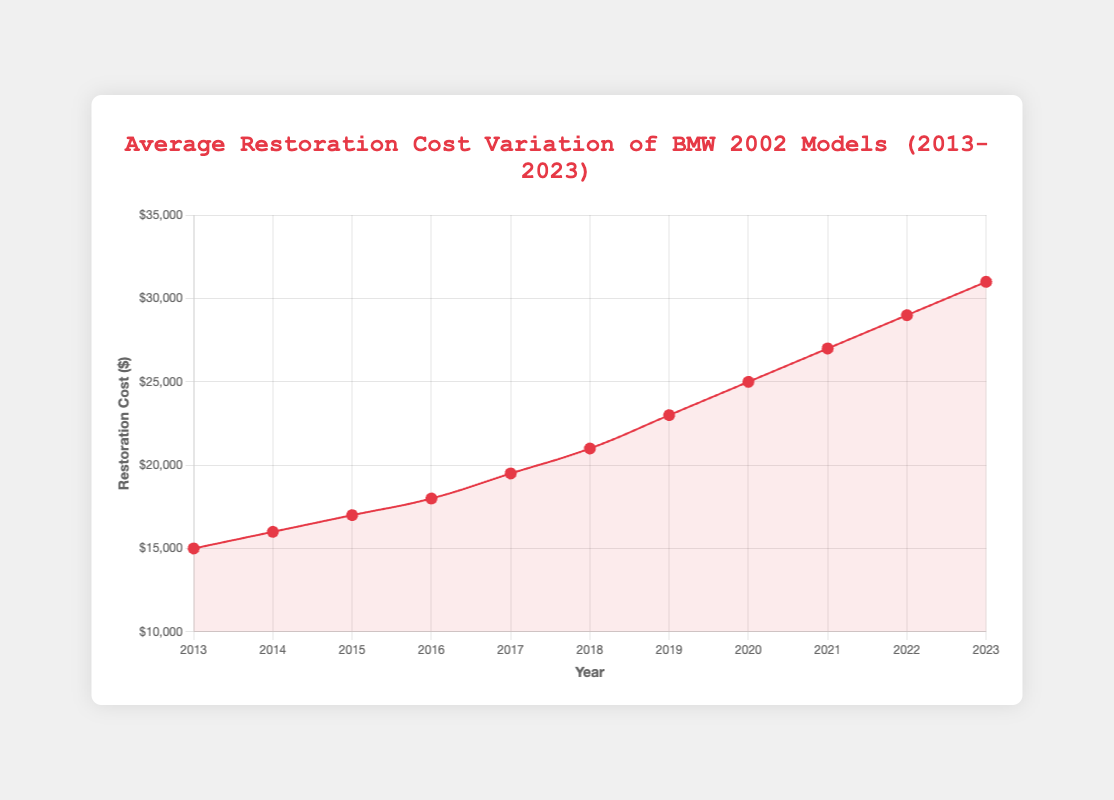What's the highest restoration cost recorded for the BMW 2002 models between 2013 and 2023? From the chart, identify the point where the cost is at its peak. The highest data point is at $31,000 in 2023.
Answer: $31,000 Which year saw the most significant increase in restoration cost compared to the previous year? Compares the differences between consecutive years: (2014-2013: +1000), (2015-2014: +1000), (2016-2015: +1000), (2017-2016: +1500), (2018-2017: +1500), (2019-2018: +2000), (2020-2019: +2000), (2021-2020: +2000), (2022-2021: +2000), (2023-2022: +2000). 2020, 2021, 2022, and 2023 show the greatest increase of $2,000 each.
Answer: 2019-2020 What is the average restoration cost of the BMW 2002 models from 2013 to 2023? Sum all the restoration costs and then divide by the number of years. The values are (15000 + 16000 + 17000 + 18000 + 19500 + 21000 + 23000 + 25000 + 27000 + 29000 + 31000) = 241500. The average is 241500 / 11 = 21,954.54.
Answer: $21,954.54 How much did the restoration cost increase from 2015 to 2018? Calculate the difference between the costs in 2018 and 2015. The cost in 2018 is $21,000 and in 2015 is $17,000. So, the increase is 21,000 - 17,000 = $4,000.
Answer: $4,000 Which model of the BMW 2002 had the restoration cost increase most frequently over the years? Find the model mentioned most frequently in the chart's tooltip for years with increased costs. Models listed are BMW 2002 tii (2013, 2017, 2021), BMW 2002 ti (2014, 2018, 2022), BMW 2002 (2015, 2019), BMW 2002 turbo (2016, 2020, 2023). Each appeared 3 times.
Answer: BMW 2002 turbo, BMW 2002 tii, BMW 2002 ti Which year had the lowest average restoration cost? From the chart's data points, identify the lowest cost. In 2013, the cost is $15,000, which is the lowest.
Answer: 2013 Is there a noticeable pattern in the restoration cost trends over the years? From the line chart, observe the overall trend. The restoration costs are steadily increasing every year.
Answer: Yes, increasing What was the restoration cost for the BMW 2002 in the year it first appears in the plot? Find the first year the model appeared and its associated cost. BMW 2002 first appeared in 2015 with a cost of $17,000.
Answer: $17,000 How does the restoration cost compare between 2016 and 2023? Compare the costs directly from the chart. In 2016 it is $18,000, and in 2023 it is $31,000.
Answer: $31,000 in 2023, much higher Which year saw a restoration cost of $21,000 for the BMW 2002 ti? Identify the year corresponding to $21,000 and BMW 2002 ti. The chart indicates 2018.
Answer: 2018 